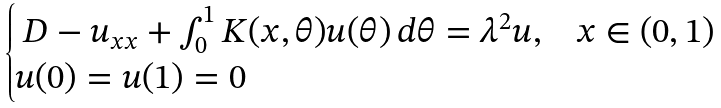Convert formula to latex. <formula><loc_0><loc_0><loc_500><loc_500>\begin{cases} \ D - u _ { x x } + \int _ { 0 } ^ { 1 } K ( x , \theta ) u ( \theta ) \, d \theta = \lambda ^ { 2 } u , & x \in ( 0 , 1 ) \\ u ( 0 ) = u ( 1 ) = 0 \end{cases}</formula> 